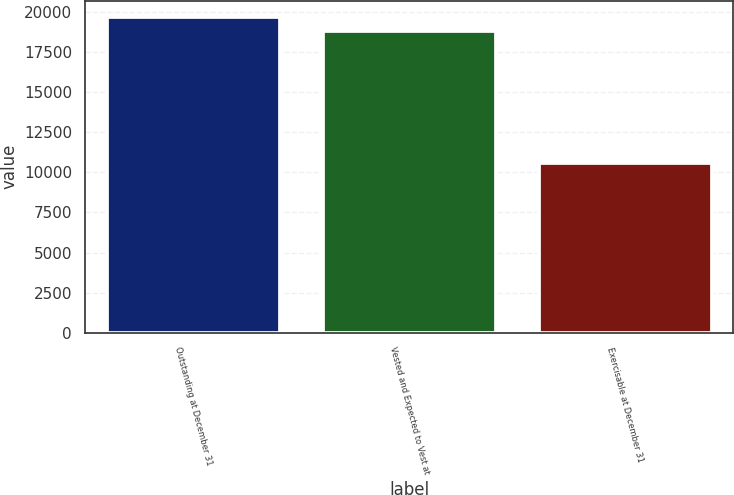Convert chart. <chart><loc_0><loc_0><loc_500><loc_500><bar_chart><fcel>Outstanding at December 31<fcel>Vested and Expected to Vest at<fcel>Exercisable at December 31<nl><fcel>19712.8<fcel>18831<fcel>10579<nl></chart> 